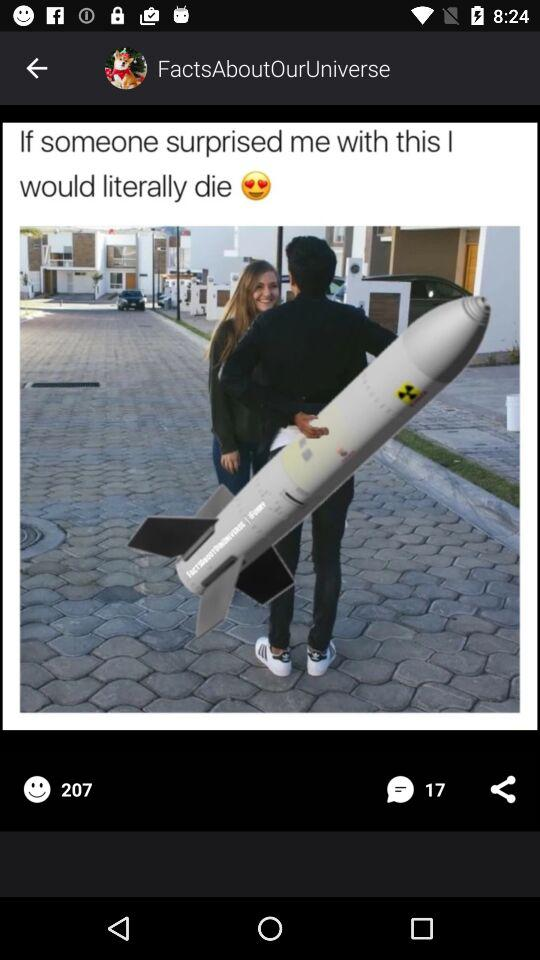How many people commented on the image? There are 17 people who commented. 